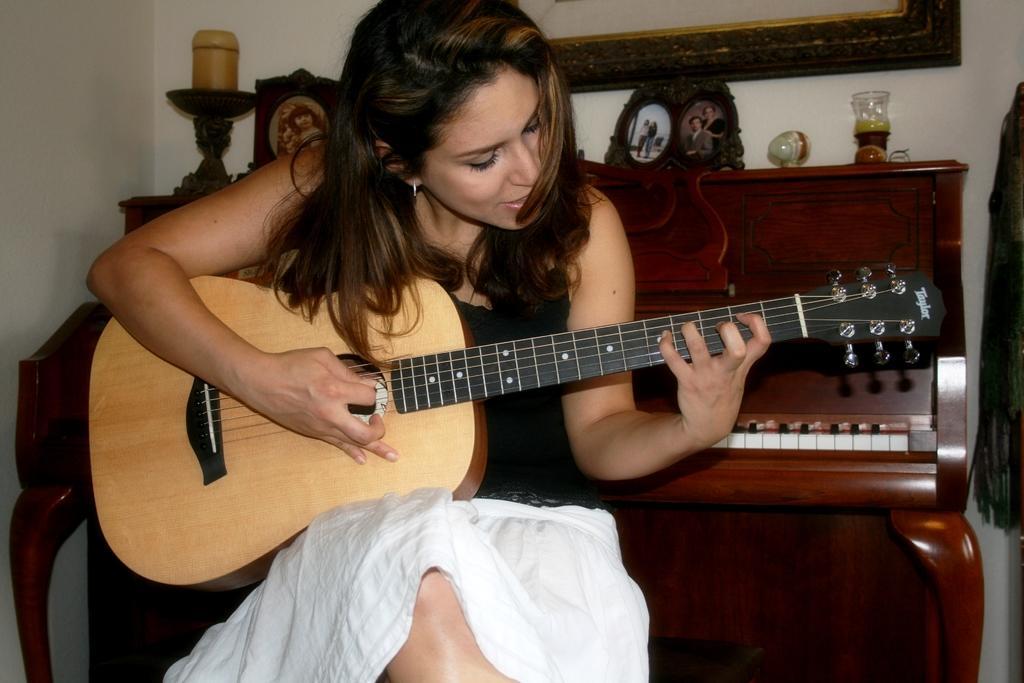Please provide a concise description of this image. In this picture there is a woman sitting and holding a guitar with her left hand and playing the guitar with your right hand in the backdrop this a piano 